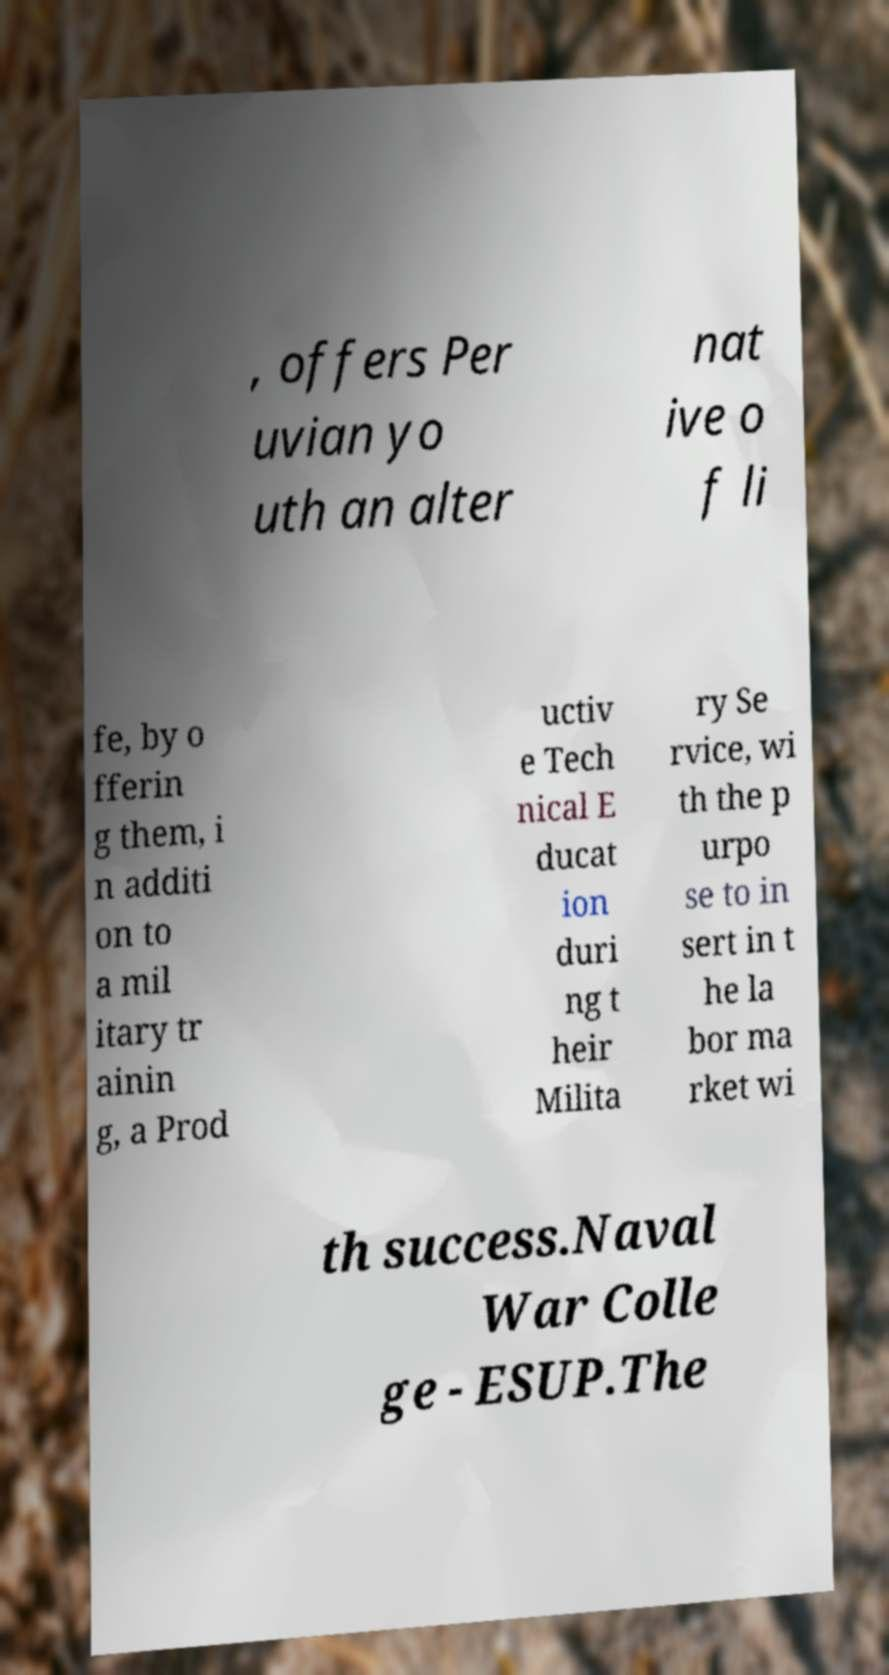Please identify and transcribe the text found in this image. , offers Per uvian yo uth an alter nat ive o f li fe, by o fferin g them, i n additi on to a mil itary tr ainin g, a Prod uctiv e Tech nical E ducat ion duri ng t heir Milita ry Se rvice, wi th the p urpo se to in sert in t he la bor ma rket wi th success.Naval War Colle ge - ESUP.The 